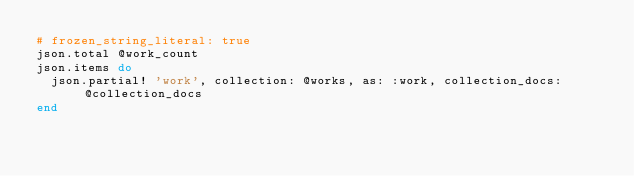Convert code to text. <code><loc_0><loc_0><loc_500><loc_500><_Ruby_># frozen_string_literal: true
json.total @work_count
json.items do
  json.partial! 'work', collection: @works, as: :work, collection_docs: @collection_docs
end
</code> 